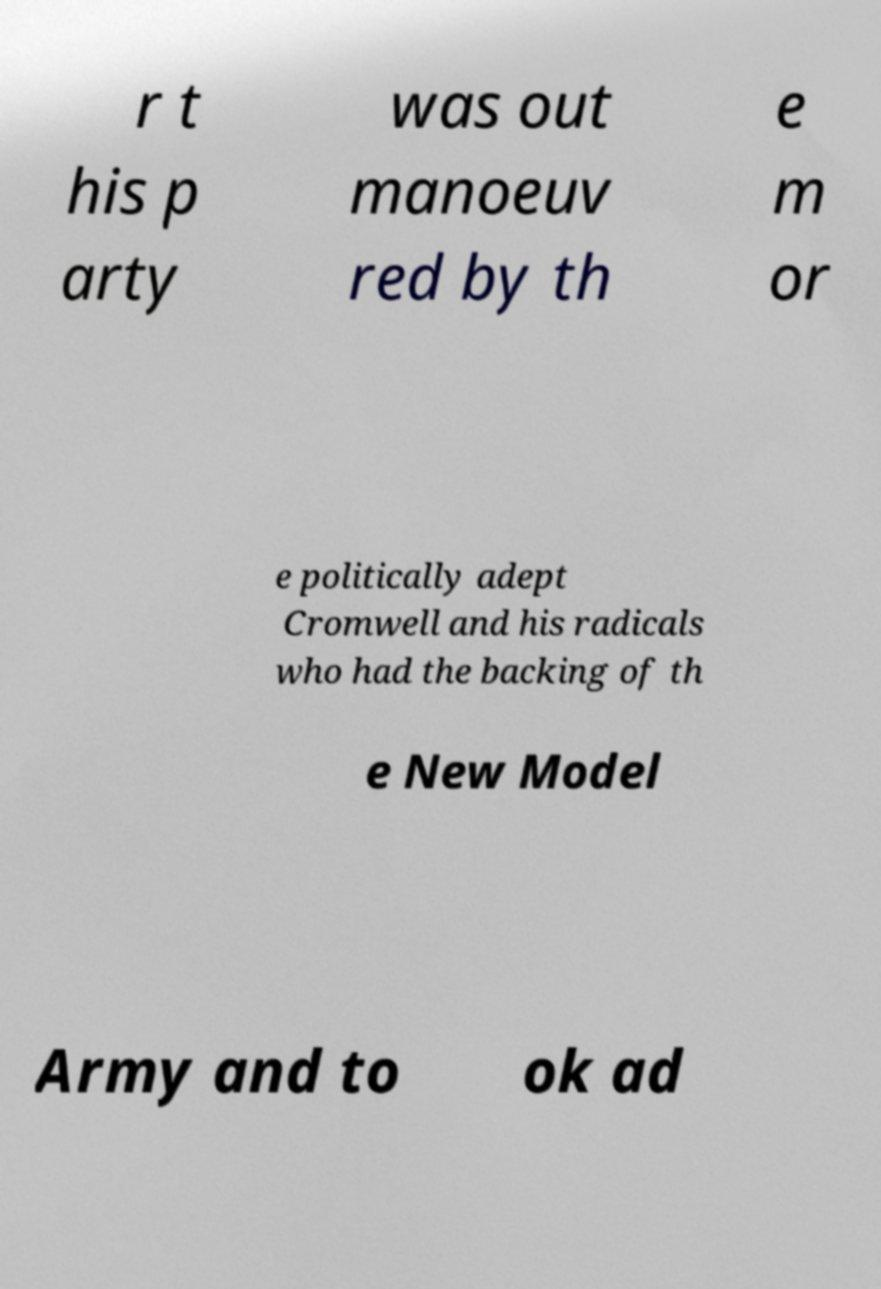Can you accurately transcribe the text from the provided image for me? r t his p arty was out manoeuv red by th e m or e politically adept Cromwell and his radicals who had the backing of th e New Model Army and to ok ad 